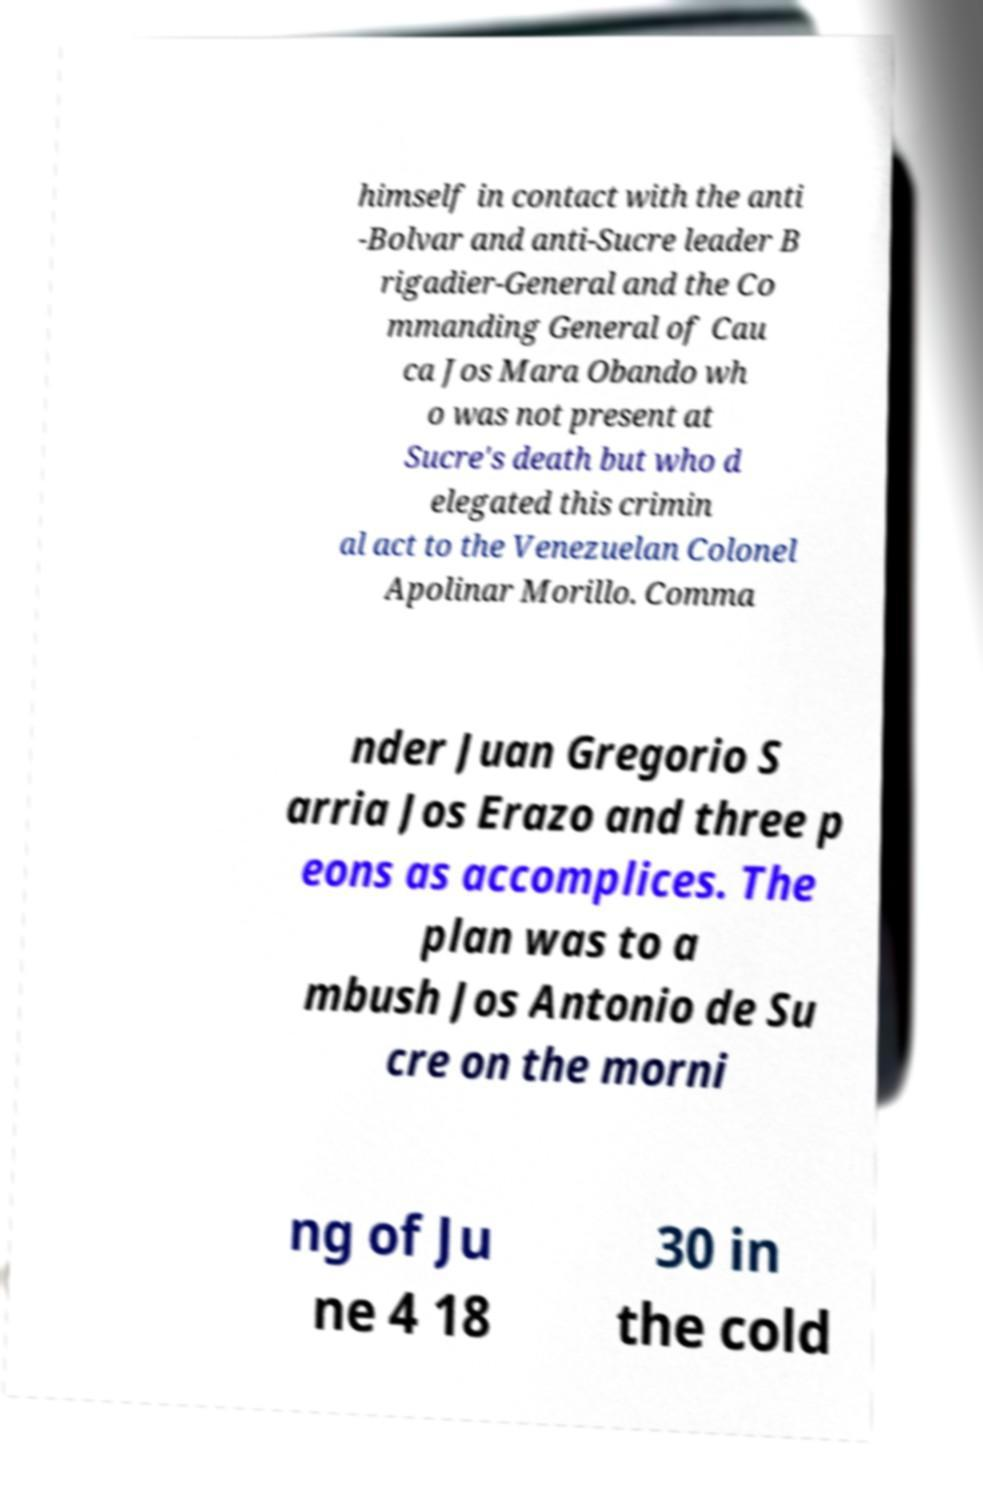Could you assist in decoding the text presented in this image and type it out clearly? himself in contact with the anti -Bolvar and anti-Sucre leader B rigadier-General and the Co mmanding General of Cau ca Jos Mara Obando wh o was not present at Sucre's death but who d elegated this crimin al act to the Venezuelan Colonel Apolinar Morillo. Comma nder Juan Gregorio S arria Jos Erazo and three p eons as accomplices. The plan was to a mbush Jos Antonio de Su cre on the morni ng of Ju ne 4 18 30 in the cold 